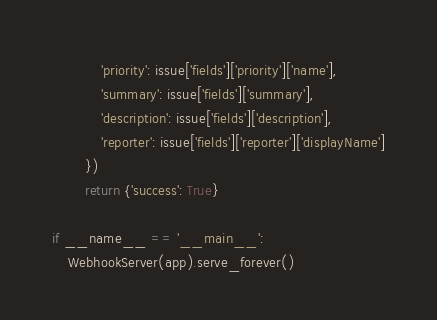Convert code to text. <code><loc_0><loc_0><loc_500><loc_500><_Python_>            'priority': issue['fields']['priority']['name'],
            'summary': issue['fields']['summary'],
            'description': issue['fields']['description'],
            'reporter': issue['fields']['reporter']['displayName']
        })
        return {'success': True}

if __name__ == '__main__':
    WebhookServer(app).serve_forever()

</code> 